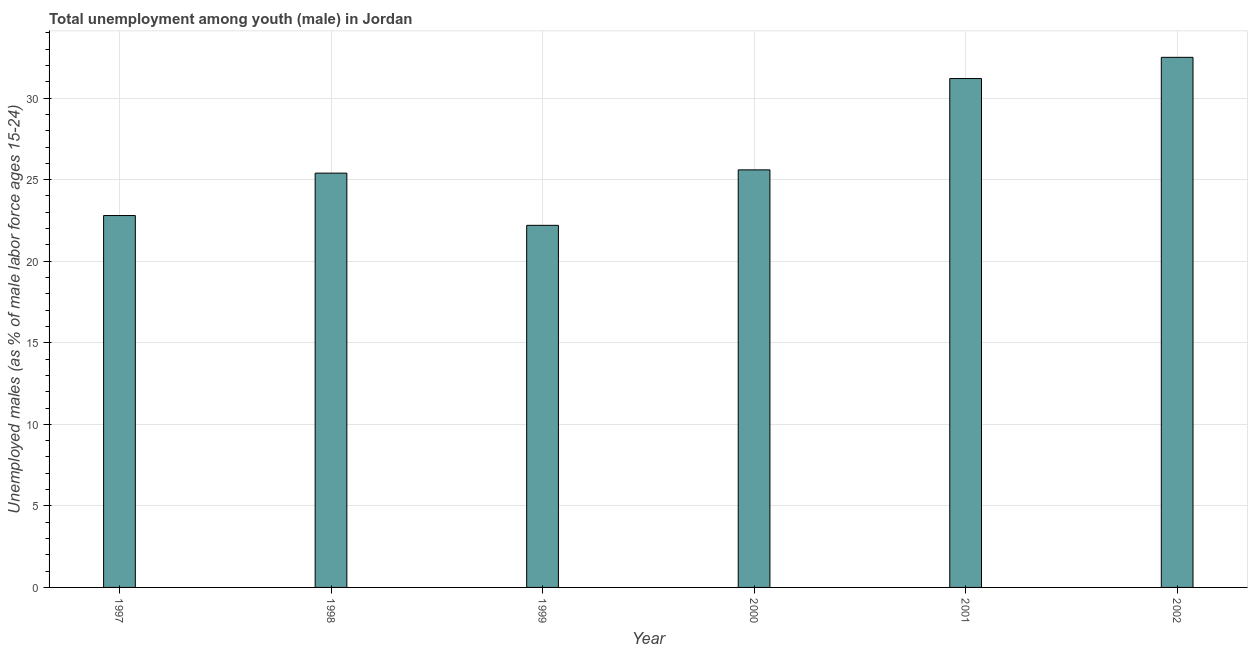What is the title of the graph?
Make the answer very short. Total unemployment among youth (male) in Jordan. What is the label or title of the Y-axis?
Give a very brief answer. Unemployed males (as % of male labor force ages 15-24). What is the unemployed male youth population in 2002?
Your response must be concise. 32.5. Across all years, what is the maximum unemployed male youth population?
Keep it short and to the point. 32.5. Across all years, what is the minimum unemployed male youth population?
Your response must be concise. 22.2. In which year was the unemployed male youth population minimum?
Ensure brevity in your answer.  1999. What is the sum of the unemployed male youth population?
Offer a terse response. 159.7. What is the difference between the unemployed male youth population in 1998 and 1999?
Offer a terse response. 3.2. What is the average unemployed male youth population per year?
Keep it short and to the point. 26.62. In how many years, is the unemployed male youth population greater than 8 %?
Provide a short and direct response. 6. What is the ratio of the unemployed male youth population in 1997 to that in 1999?
Ensure brevity in your answer.  1.03. Is the unemployed male youth population in 1997 less than that in 1999?
Your answer should be compact. No. Is the difference between the unemployed male youth population in 1997 and 1999 greater than the difference between any two years?
Provide a succinct answer. No. In how many years, is the unemployed male youth population greater than the average unemployed male youth population taken over all years?
Your answer should be very brief. 2. What is the Unemployed males (as % of male labor force ages 15-24) in 1997?
Your answer should be very brief. 22.8. What is the Unemployed males (as % of male labor force ages 15-24) in 1998?
Offer a very short reply. 25.4. What is the Unemployed males (as % of male labor force ages 15-24) in 1999?
Provide a short and direct response. 22.2. What is the Unemployed males (as % of male labor force ages 15-24) in 2000?
Your answer should be very brief. 25.6. What is the Unemployed males (as % of male labor force ages 15-24) in 2001?
Your answer should be very brief. 31.2. What is the Unemployed males (as % of male labor force ages 15-24) of 2002?
Keep it short and to the point. 32.5. What is the difference between the Unemployed males (as % of male labor force ages 15-24) in 1997 and 1998?
Your response must be concise. -2.6. What is the difference between the Unemployed males (as % of male labor force ages 15-24) in 1997 and 2002?
Your answer should be very brief. -9.7. What is the difference between the Unemployed males (as % of male labor force ages 15-24) in 1998 and 1999?
Provide a succinct answer. 3.2. What is the difference between the Unemployed males (as % of male labor force ages 15-24) in 1998 and 2002?
Offer a terse response. -7.1. What is the difference between the Unemployed males (as % of male labor force ages 15-24) in 1999 and 2000?
Ensure brevity in your answer.  -3.4. What is the difference between the Unemployed males (as % of male labor force ages 15-24) in 1999 and 2002?
Make the answer very short. -10.3. What is the ratio of the Unemployed males (as % of male labor force ages 15-24) in 1997 to that in 1998?
Keep it short and to the point. 0.9. What is the ratio of the Unemployed males (as % of male labor force ages 15-24) in 1997 to that in 1999?
Your response must be concise. 1.03. What is the ratio of the Unemployed males (as % of male labor force ages 15-24) in 1997 to that in 2000?
Offer a very short reply. 0.89. What is the ratio of the Unemployed males (as % of male labor force ages 15-24) in 1997 to that in 2001?
Ensure brevity in your answer.  0.73. What is the ratio of the Unemployed males (as % of male labor force ages 15-24) in 1997 to that in 2002?
Your answer should be very brief. 0.7. What is the ratio of the Unemployed males (as % of male labor force ages 15-24) in 1998 to that in 1999?
Your answer should be compact. 1.14. What is the ratio of the Unemployed males (as % of male labor force ages 15-24) in 1998 to that in 2000?
Give a very brief answer. 0.99. What is the ratio of the Unemployed males (as % of male labor force ages 15-24) in 1998 to that in 2001?
Provide a succinct answer. 0.81. What is the ratio of the Unemployed males (as % of male labor force ages 15-24) in 1998 to that in 2002?
Keep it short and to the point. 0.78. What is the ratio of the Unemployed males (as % of male labor force ages 15-24) in 1999 to that in 2000?
Provide a short and direct response. 0.87. What is the ratio of the Unemployed males (as % of male labor force ages 15-24) in 1999 to that in 2001?
Provide a short and direct response. 0.71. What is the ratio of the Unemployed males (as % of male labor force ages 15-24) in 1999 to that in 2002?
Offer a very short reply. 0.68. What is the ratio of the Unemployed males (as % of male labor force ages 15-24) in 2000 to that in 2001?
Your response must be concise. 0.82. What is the ratio of the Unemployed males (as % of male labor force ages 15-24) in 2000 to that in 2002?
Your answer should be very brief. 0.79. What is the ratio of the Unemployed males (as % of male labor force ages 15-24) in 2001 to that in 2002?
Make the answer very short. 0.96. 